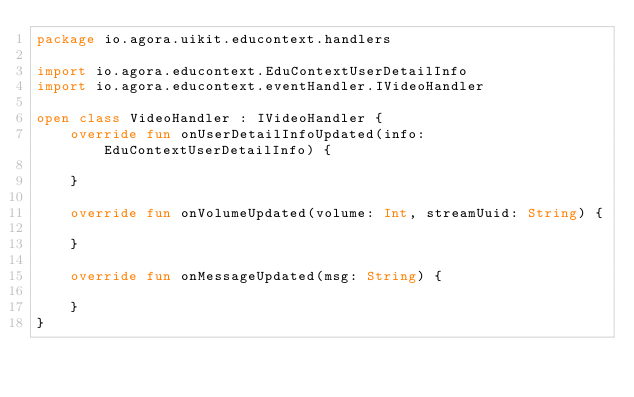Convert code to text. <code><loc_0><loc_0><loc_500><loc_500><_Kotlin_>package io.agora.uikit.educontext.handlers

import io.agora.educontext.EduContextUserDetailInfo
import io.agora.educontext.eventHandler.IVideoHandler

open class VideoHandler : IVideoHandler {
    override fun onUserDetailInfoUpdated(info: EduContextUserDetailInfo) {

    }

    override fun onVolumeUpdated(volume: Int, streamUuid: String) {

    }

    override fun onMessageUpdated(msg: String) {

    }
}</code> 